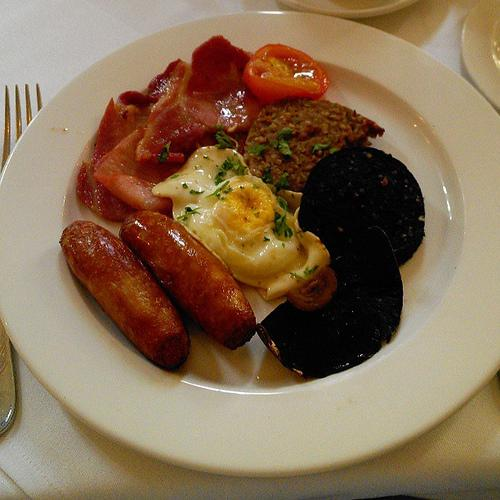What items are present on the plate in the photo? The plate has a fried egg, sausages, tomato, and some green seasoning on it. How many sausages can be seen in the image and where are they located? There are two sausages on the plate in the image. Count the number of tomatoes visible in the image. There is one tomato on the plate in the image. What kind of sentiment or emotion do you associate with this image? The image evokes a feeling of satisfaction, as it displays a hearty and appetizing breakfast meal. In a formal manner, describe the utensil near the plate. A silver fork is situated adjacent to the plate, demonstrating tines that are clearly visible. Using simple words, explain what is in the center of the image. A fried egg is in the center of the image. What type of reasoning task could be performed using the information in the image? One could infer the ingredients used to prepare the meal or determine the nutritional content of the breakfast. Identify the main food items present in the image and assess their quality. The main food items are a fried egg, sausages, and a tomato. They appear to be well-prepared and fresh. Analyze the interaction between the food items and the utensil in the image. The silver fork is placed on the side of the plate, ready to be used to eat the meal, but not directly interacting with the food items. Can you spot any specific color on the plate, and if so, what is it? Yes, there is red color from the tomato and the yellow from the egg yolk on the plate. Do the sausages have black stripes on them? No, it's not mentioned in the image. 